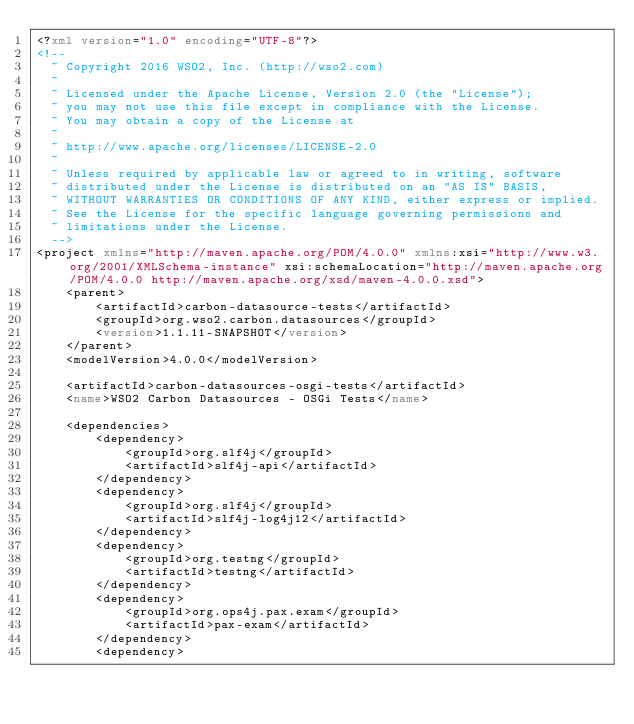<code> <loc_0><loc_0><loc_500><loc_500><_XML_><?xml version="1.0" encoding="UTF-8"?>
<!--
  ~ Copyright 2016 WSO2, Inc. (http://wso2.com)
  ~
  ~ Licensed under the Apache License, Version 2.0 (the "License");
  ~ you may not use this file except in compliance with the License.
  ~ You may obtain a copy of the License at
  ~
  ~ http://www.apache.org/licenses/LICENSE-2.0
  ~
  ~ Unless required by applicable law or agreed to in writing, software
  ~ distributed under the License is distributed on an "AS IS" BASIS,
  ~ WITHOUT WARRANTIES OR CONDITIONS OF ANY KIND, either express or implied.
  ~ See the License for the specific language governing permissions and
  ~ limitations under the License.
  -->
<project xmlns="http://maven.apache.org/POM/4.0.0" xmlns:xsi="http://www.w3.org/2001/XMLSchema-instance" xsi:schemaLocation="http://maven.apache.org/POM/4.0.0 http://maven.apache.org/xsd/maven-4.0.0.xsd">
    <parent>
        <artifactId>carbon-datasource-tests</artifactId>
        <groupId>org.wso2.carbon.datasources</groupId>
        <version>1.1.11-SNAPSHOT</version>
    </parent>
    <modelVersion>4.0.0</modelVersion>

    <artifactId>carbon-datasources-osgi-tests</artifactId>
    <name>WSO2 Carbon Datasources - OSGi Tests</name>

    <dependencies>
        <dependency>
            <groupId>org.slf4j</groupId>
            <artifactId>slf4j-api</artifactId>
        </dependency>
        <dependency>
            <groupId>org.slf4j</groupId>
            <artifactId>slf4j-log4j12</artifactId>
        </dependency>
        <dependency>
            <groupId>org.testng</groupId>
            <artifactId>testng</artifactId>
        </dependency>
        <dependency>
            <groupId>org.ops4j.pax.exam</groupId>
            <artifactId>pax-exam</artifactId>
        </dependency>
        <dependency></code> 